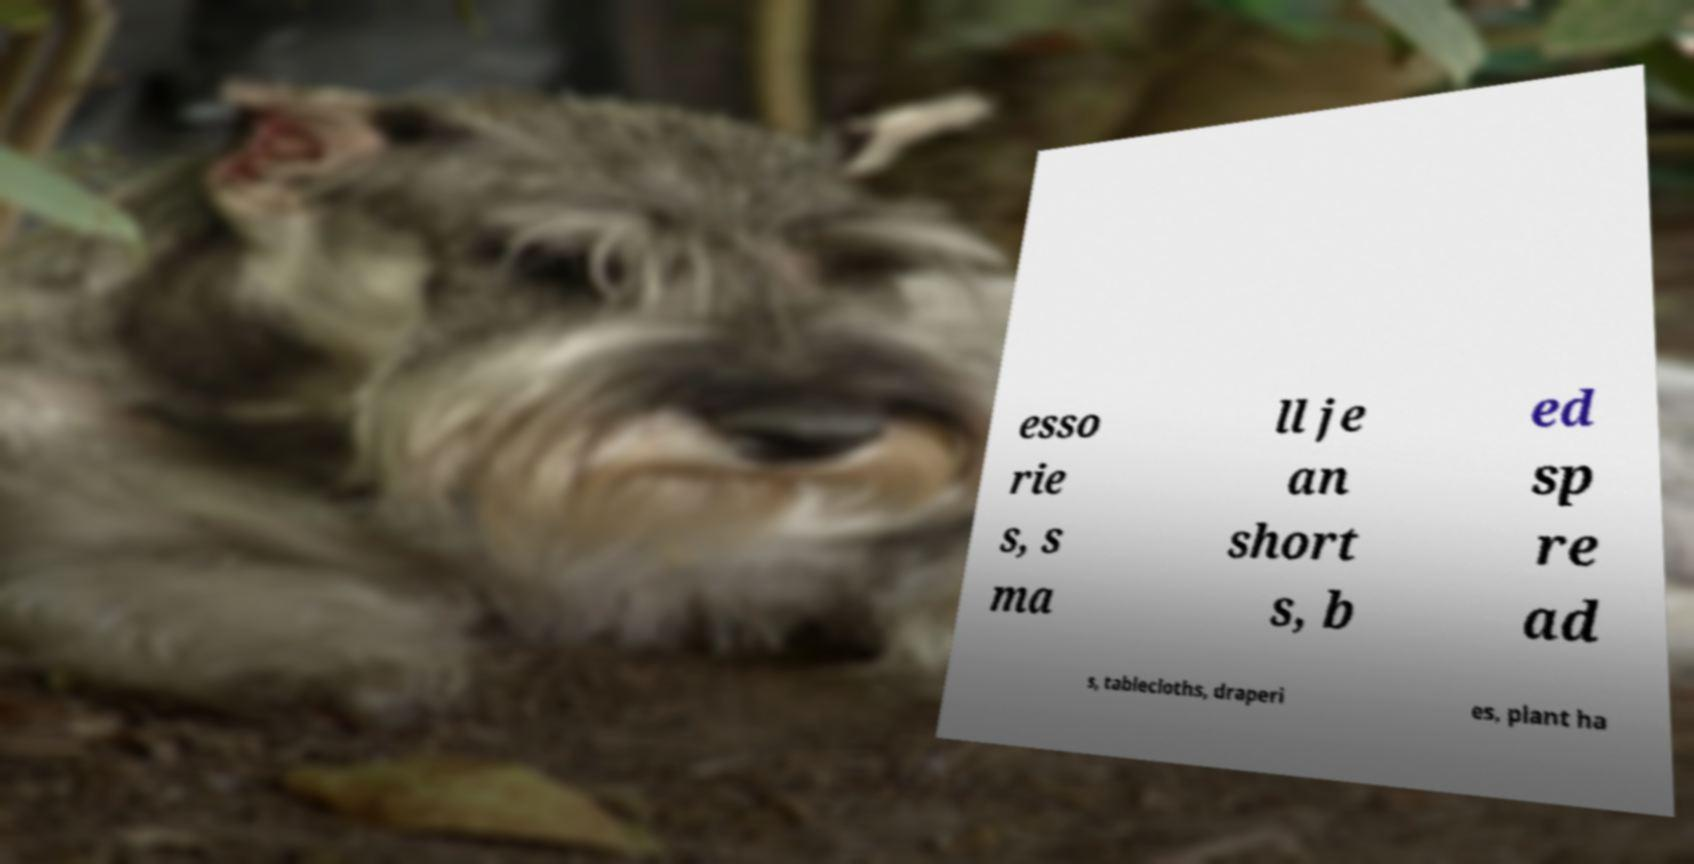Could you extract and type out the text from this image? esso rie s, s ma ll je an short s, b ed sp re ad s, tablecloths, draperi es, plant ha 